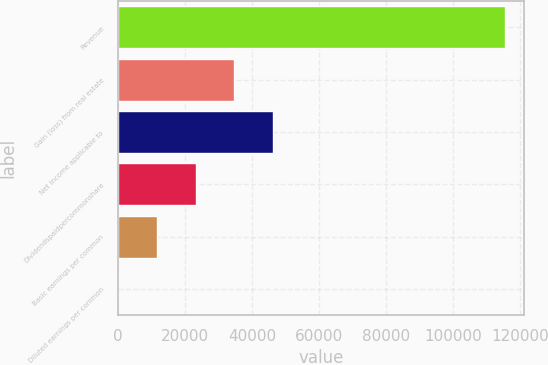Convert chart to OTSL. <chart><loc_0><loc_0><loc_500><loc_500><bar_chart><fcel>Revenue<fcel>Gain (loss) from real estate<fcel>Net income applicable to<fcel>Dividendspaidpercommonshare<fcel>Basic earnings per common<fcel>Diluted earnings per common<nl><fcel>115449<fcel>34634.9<fcel>46179.8<fcel>23090<fcel>11545.2<fcel>0.3<nl></chart> 